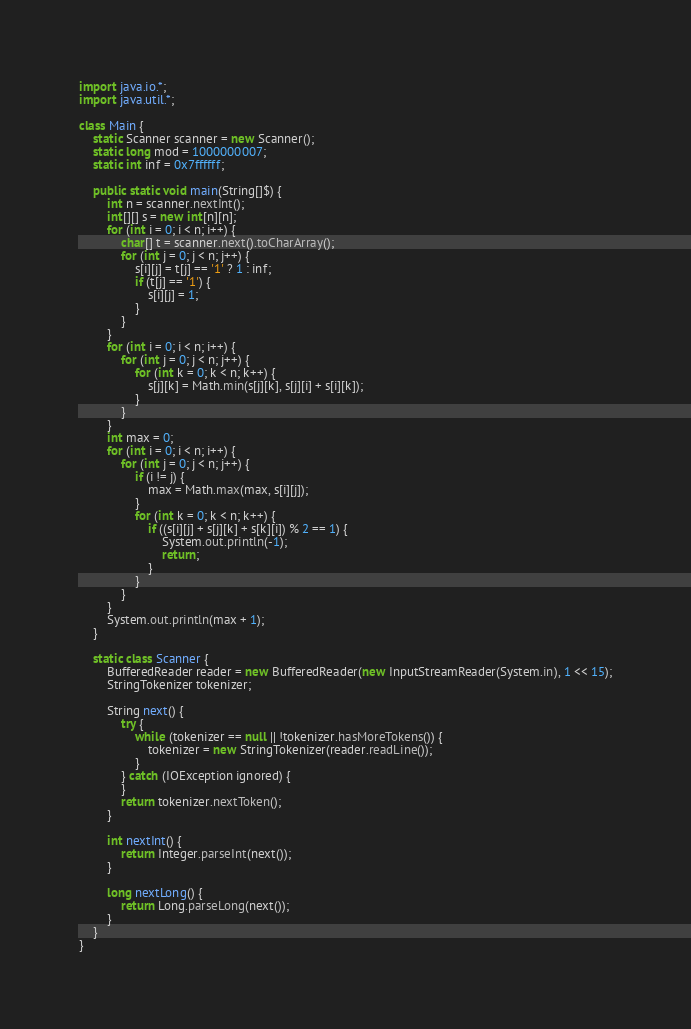Convert code to text. <code><loc_0><loc_0><loc_500><loc_500><_Java_>import java.io.*;
import java.util.*;

class Main {
    static Scanner scanner = new Scanner();
    static long mod = 1000000007;
    static int inf = 0x7ffffff;

    public static void main(String[]$) {
        int n = scanner.nextInt();
        int[][] s = new int[n][n];
        for (int i = 0; i < n; i++) {
            char[] t = scanner.next().toCharArray();
            for (int j = 0; j < n; j++) {
                s[i][j] = t[j] == '1' ? 1 : inf;
                if (t[j] == '1') {
                    s[i][j] = 1;
                }
            }
        }
        for (int i = 0; i < n; i++) {
            for (int j = 0; j < n; j++) {
                for (int k = 0; k < n; k++) {
                    s[j][k] = Math.min(s[j][k], s[j][i] + s[i][k]);
                }
            }
        }
        int max = 0;
        for (int i = 0; i < n; i++) {
            for (int j = 0; j < n; j++) {
                if (i != j) {
                    max = Math.max(max, s[i][j]);
                }
                for (int k = 0; k < n; k++) {
                    if ((s[i][j] + s[j][k] + s[k][i]) % 2 == 1) {
                        System.out.println(-1);
                        return;
                    }
                }
            }
        }
        System.out.println(max + 1);
    }

    static class Scanner {
        BufferedReader reader = new BufferedReader(new InputStreamReader(System.in), 1 << 15);
        StringTokenizer tokenizer;

        String next() {
            try {
                while (tokenizer == null || !tokenizer.hasMoreTokens()) {
                    tokenizer = new StringTokenizer(reader.readLine());
                }
            } catch (IOException ignored) {
            }
            return tokenizer.nextToken();
        }

        int nextInt() {
            return Integer.parseInt(next());
        }

        long nextLong() {
            return Long.parseLong(next());
        }
    }
}
</code> 